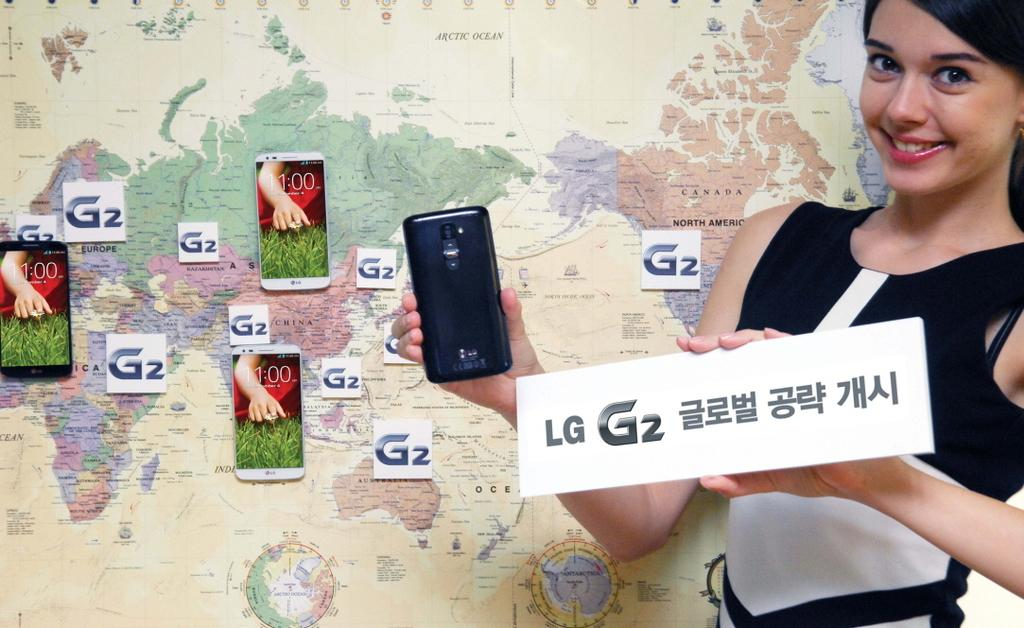Who is present in the image? There is a woman in the image. What is the woman doing in the image? The woman is standing in front of a map. What object is the woman holding in the image? The woman is holding a mobile phone. Can you describe any additional details about the mobile phone? There is an LG sticker on the mobile phone. What else can be seen in the image related to mobile phones? There are other mobile phones visible in the image. Are there any stickers present in the image besides the LG sticker? Yes, there are stickers on the wall in the image. What type of glass is the woman drinking from in the image? There is no glass present in the image; the woman is holding a mobile phone. Can you see a rifle in the image? No, there is no rifle present in the image. 